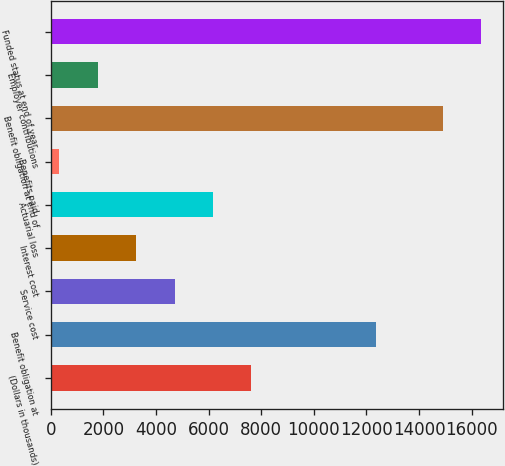<chart> <loc_0><loc_0><loc_500><loc_500><bar_chart><fcel>(Dollars in thousands)<fcel>Benefit obligation at<fcel>Service cost<fcel>Interest cost<fcel>Actuarial loss<fcel>Benefits paid<fcel>Benefit obligation at end of<fcel>Employer contributions<fcel>Funded status at end of year<nl><fcel>7625.5<fcel>12356<fcel>4708.1<fcel>3249.4<fcel>6166.8<fcel>332<fcel>14919<fcel>1790.7<fcel>16377.7<nl></chart> 